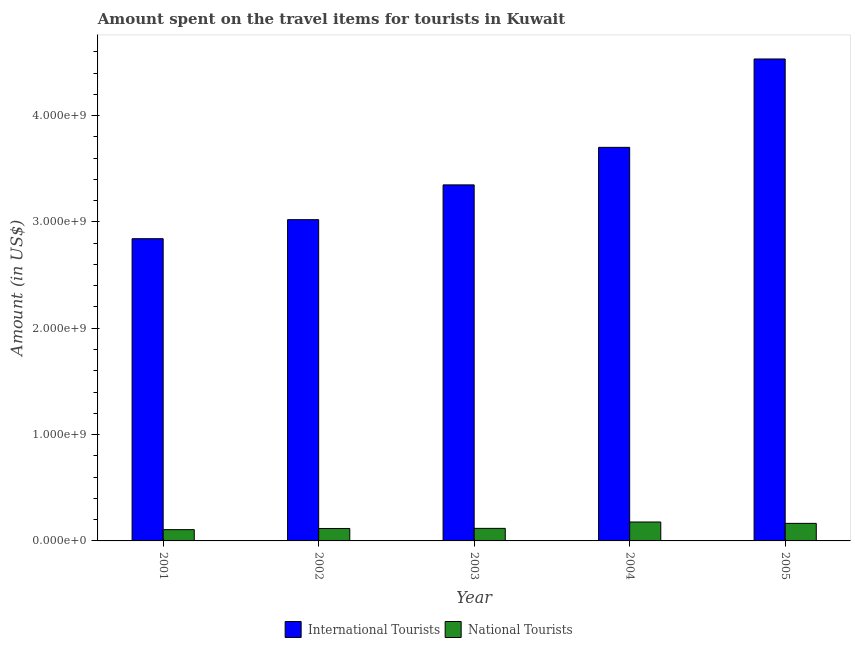How many groups of bars are there?
Provide a short and direct response. 5. Are the number of bars on each tick of the X-axis equal?
Ensure brevity in your answer.  Yes. How many bars are there on the 4th tick from the right?
Provide a succinct answer. 2. What is the label of the 5th group of bars from the left?
Provide a short and direct response. 2005. In how many cases, is the number of bars for a given year not equal to the number of legend labels?
Offer a very short reply. 0. What is the amount spent on travel items of international tourists in 2004?
Keep it short and to the point. 3.70e+09. Across all years, what is the maximum amount spent on travel items of international tourists?
Offer a terse response. 4.53e+09. Across all years, what is the minimum amount spent on travel items of national tourists?
Make the answer very short. 1.06e+08. In which year was the amount spent on travel items of international tourists minimum?
Your answer should be compact. 2001. What is the total amount spent on travel items of national tourists in the graph?
Make the answer very short. 6.84e+08. What is the difference between the amount spent on travel items of international tourists in 2003 and that in 2004?
Make the answer very short. -3.53e+08. What is the difference between the amount spent on travel items of national tourists in 2005 and the amount spent on travel items of international tourists in 2002?
Offer a terse response. 4.80e+07. What is the average amount spent on travel items of national tourists per year?
Keep it short and to the point. 1.37e+08. In the year 2001, what is the difference between the amount spent on travel items of national tourists and amount spent on travel items of international tourists?
Your response must be concise. 0. In how many years, is the amount spent on travel items of national tourists greater than 3400000000 US$?
Provide a short and direct response. 0. What is the ratio of the amount spent on travel items of national tourists in 2001 to that in 2002?
Give a very brief answer. 0.91. Is the amount spent on travel items of international tourists in 2001 less than that in 2002?
Provide a short and direct response. Yes. Is the difference between the amount spent on travel items of international tourists in 2001 and 2003 greater than the difference between the amount spent on travel items of national tourists in 2001 and 2003?
Offer a terse response. No. What is the difference between the highest and the second highest amount spent on travel items of national tourists?
Offer a very short reply. 1.30e+07. What is the difference between the highest and the lowest amount spent on travel items of national tourists?
Keep it short and to the point. 7.20e+07. What does the 2nd bar from the left in 2001 represents?
Provide a succinct answer. National Tourists. What does the 1st bar from the right in 2002 represents?
Offer a terse response. National Tourists. Are all the bars in the graph horizontal?
Offer a very short reply. No. Does the graph contain grids?
Provide a short and direct response. No. How many legend labels are there?
Ensure brevity in your answer.  2. What is the title of the graph?
Ensure brevity in your answer.  Amount spent on the travel items for tourists in Kuwait. Does "Taxes on exports" appear as one of the legend labels in the graph?
Provide a short and direct response. No. What is the label or title of the Y-axis?
Make the answer very short. Amount (in US$). What is the Amount (in US$) in International Tourists in 2001?
Give a very brief answer. 2.84e+09. What is the Amount (in US$) in National Tourists in 2001?
Make the answer very short. 1.06e+08. What is the Amount (in US$) of International Tourists in 2002?
Make the answer very short. 3.02e+09. What is the Amount (in US$) in National Tourists in 2002?
Offer a terse response. 1.17e+08. What is the Amount (in US$) of International Tourists in 2003?
Make the answer very short. 3.35e+09. What is the Amount (in US$) in National Tourists in 2003?
Ensure brevity in your answer.  1.18e+08. What is the Amount (in US$) in International Tourists in 2004?
Your response must be concise. 3.70e+09. What is the Amount (in US$) of National Tourists in 2004?
Your response must be concise. 1.78e+08. What is the Amount (in US$) of International Tourists in 2005?
Ensure brevity in your answer.  4.53e+09. What is the Amount (in US$) of National Tourists in 2005?
Make the answer very short. 1.65e+08. Across all years, what is the maximum Amount (in US$) in International Tourists?
Give a very brief answer. 4.53e+09. Across all years, what is the maximum Amount (in US$) of National Tourists?
Ensure brevity in your answer.  1.78e+08. Across all years, what is the minimum Amount (in US$) in International Tourists?
Give a very brief answer. 2.84e+09. Across all years, what is the minimum Amount (in US$) in National Tourists?
Ensure brevity in your answer.  1.06e+08. What is the total Amount (in US$) in International Tourists in the graph?
Keep it short and to the point. 1.74e+1. What is the total Amount (in US$) in National Tourists in the graph?
Ensure brevity in your answer.  6.84e+08. What is the difference between the Amount (in US$) of International Tourists in 2001 and that in 2002?
Make the answer very short. -1.79e+08. What is the difference between the Amount (in US$) of National Tourists in 2001 and that in 2002?
Offer a very short reply. -1.10e+07. What is the difference between the Amount (in US$) of International Tourists in 2001 and that in 2003?
Offer a very short reply. -5.06e+08. What is the difference between the Amount (in US$) in National Tourists in 2001 and that in 2003?
Make the answer very short. -1.20e+07. What is the difference between the Amount (in US$) in International Tourists in 2001 and that in 2004?
Keep it short and to the point. -8.59e+08. What is the difference between the Amount (in US$) in National Tourists in 2001 and that in 2004?
Provide a succinct answer. -7.20e+07. What is the difference between the Amount (in US$) of International Tourists in 2001 and that in 2005?
Make the answer very short. -1.69e+09. What is the difference between the Amount (in US$) in National Tourists in 2001 and that in 2005?
Ensure brevity in your answer.  -5.90e+07. What is the difference between the Amount (in US$) of International Tourists in 2002 and that in 2003?
Ensure brevity in your answer.  -3.27e+08. What is the difference between the Amount (in US$) in International Tourists in 2002 and that in 2004?
Provide a succinct answer. -6.80e+08. What is the difference between the Amount (in US$) in National Tourists in 2002 and that in 2004?
Offer a terse response. -6.10e+07. What is the difference between the Amount (in US$) in International Tourists in 2002 and that in 2005?
Provide a short and direct response. -1.51e+09. What is the difference between the Amount (in US$) of National Tourists in 2002 and that in 2005?
Ensure brevity in your answer.  -4.80e+07. What is the difference between the Amount (in US$) in International Tourists in 2003 and that in 2004?
Provide a succinct answer. -3.53e+08. What is the difference between the Amount (in US$) in National Tourists in 2003 and that in 2004?
Offer a very short reply. -6.00e+07. What is the difference between the Amount (in US$) of International Tourists in 2003 and that in 2005?
Provide a short and direct response. -1.18e+09. What is the difference between the Amount (in US$) in National Tourists in 2003 and that in 2005?
Provide a succinct answer. -4.70e+07. What is the difference between the Amount (in US$) of International Tourists in 2004 and that in 2005?
Keep it short and to the point. -8.31e+08. What is the difference between the Amount (in US$) in National Tourists in 2004 and that in 2005?
Make the answer very short. 1.30e+07. What is the difference between the Amount (in US$) in International Tourists in 2001 and the Amount (in US$) in National Tourists in 2002?
Your response must be concise. 2.72e+09. What is the difference between the Amount (in US$) of International Tourists in 2001 and the Amount (in US$) of National Tourists in 2003?
Your response must be concise. 2.72e+09. What is the difference between the Amount (in US$) in International Tourists in 2001 and the Amount (in US$) in National Tourists in 2004?
Provide a short and direct response. 2.66e+09. What is the difference between the Amount (in US$) of International Tourists in 2001 and the Amount (in US$) of National Tourists in 2005?
Your response must be concise. 2.68e+09. What is the difference between the Amount (in US$) in International Tourists in 2002 and the Amount (in US$) in National Tourists in 2003?
Provide a succinct answer. 2.90e+09. What is the difference between the Amount (in US$) in International Tourists in 2002 and the Amount (in US$) in National Tourists in 2004?
Offer a very short reply. 2.84e+09. What is the difference between the Amount (in US$) of International Tourists in 2002 and the Amount (in US$) of National Tourists in 2005?
Your response must be concise. 2.86e+09. What is the difference between the Amount (in US$) in International Tourists in 2003 and the Amount (in US$) in National Tourists in 2004?
Provide a succinct answer. 3.17e+09. What is the difference between the Amount (in US$) of International Tourists in 2003 and the Amount (in US$) of National Tourists in 2005?
Provide a succinct answer. 3.18e+09. What is the difference between the Amount (in US$) in International Tourists in 2004 and the Amount (in US$) in National Tourists in 2005?
Your response must be concise. 3.54e+09. What is the average Amount (in US$) in International Tourists per year?
Give a very brief answer. 3.49e+09. What is the average Amount (in US$) in National Tourists per year?
Make the answer very short. 1.37e+08. In the year 2001, what is the difference between the Amount (in US$) in International Tourists and Amount (in US$) in National Tourists?
Give a very brief answer. 2.74e+09. In the year 2002, what is the difference between the Amount (in US$) in International Tourists and Amount (in US$) in National Tourists?
Ensure brevity in your answer.  2.90e+09. In the year 2003, what is the difference between the Amount (in US$) of International Tourists and Amount (in US$) of National Tourists?
Your answer should be compact. 3.23e+09. In the year 2004, what is the difference between the Amount (in US$) of International Tourists and Amount (in US$) of National Tourists?
Make the answer very short. 3.52e+09. In the year 2005, what is the difference between the Amount (in US$) of International Tourists and Amount (in US$) of National Tourists?
Make the answer very short. 4.37e+09. What is the ratio of the Amount (in US$) of International Tourists in 2001 to that in 2002?
Give a very brief answer. 0.94. What is the ratio of the Amount (in US$) in National Tourists in 2001 to that in 2002?
Provide a succinct answer. 0.91. What is the ratio of the Amount (in US$) in International Tourists in 2001 to that in 2003?
Keep it short and to the point. 0.85. What is the ratio of the Amount (in US$) in National Tourists in 2001 to that in 2003?
Your response must be concise. 0.9. What is the ratio of the Amount (in US$) in International Tourists in 2001 to that in 2004?
Ensure brevity in your answer.  0.77. What is the ratio of the Amount (in US$) of National Tourists in 2001 to that in 2004?
Provide a succinct answer. 0.6. What is the ratio of the Amount (in US$) in International Tourists in 2001 to that in 2005?
Provide a short and direct response. 0.63. What is the ratio of the Amount (in US$) of National Tourists in 2001 to that in 2005?
Provide a short and direct response. 0.64. What is the ratio of the Amount (in US$) of International Tourists in 2002 to that in 2003?
Your answer should be compact. 0.9. What is the ratio of the Amount (in US$) of National Tourists in 2002 to that in 2003?
Make the answer very short. 0.99. What is the ratio of the Amount (in US$) of International Tourists in 2002 to that in 2004?
Your response must be concise. 0.82. What is the ratio of the Amount (in US$) of National Tourists in 2002 to that in 2004?
Make the answer very short. 0.66. What is the ratio of the Amount (in US$) of International Tourists in 2002 to that in 2005?
Offer a very short reply. 0.67. What is the ratio of the Amount (in US$) of National Tourists in 2002 to that in 2005?
Keep it short and to the point. 0.71. What is the ratio of the Amount (in US$) in International Tourists in 2003 to that in 2004?
Ensure brevity in your answer.  0.9. What is the ratio of the Amount (in US$) of National Tourists in 2003 to that in 2004?
Your answer should be very brief. 0.66. What is the ratio of the Amount (in US$) in International Tourists in 2003 to that in 2005?
Offer a very short reply. 0.74. What is the ratio of the Amount (in US$) of National Tourists in 2003 to that in 2005?
Your response must be concise. 0.72. What is the ratio of the Amount (in US$) of International Tourists in 2004 to that in 2005?
Provide a succinct answer. 0.82. What is the ratio of the Amount (in US$) in National Tourists in 2004 to that in 2005?
Give a very brief answer. 1.08. What is the difference between the highest and the second highest Amount (in US$) of International Tourists?
Provide a short and direct response. 8.31e+08. What is the difference between the highest and the second highest Amount (in US$) in National Tourists?
Offer a very short reply. 1.30e+07. What is the difference between the highest and the lowest Amount (in US$) of International Tourists?
Your answer should be compact. 1.69e+09. What is the difference between the highest and the lowest Amount (in US$) in National Tourists?
Keep it short and to the point. 7.20e+07. 